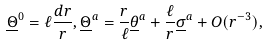<formula> <loc_0><loc_0><loc_500><loc_500>\underline { \Theta } ^ { 0 } = \ell \frac { d r } { r } , \underline { \Theta } ^ { a } = \frac { r } { \ell } \underline { \theta } ^ { a } + \frac { \ell } { r } \underline { \sigma } ^ { a } + O ( r ^ { - 3 } ) ,</formula> 